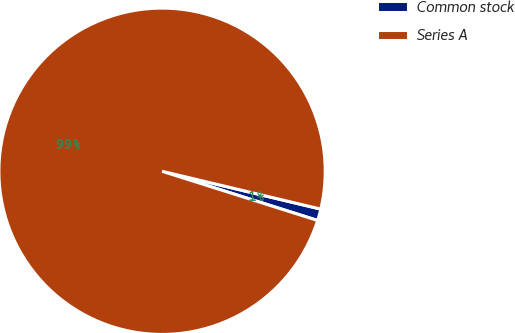Convert chart. <chart><loc_0><loc_0><loc_500><loc_500><pie_chart><fcel>Common stock<fcel>Series A<nl><fcel>1.15%<fcel>98.85%<nl></chart> 